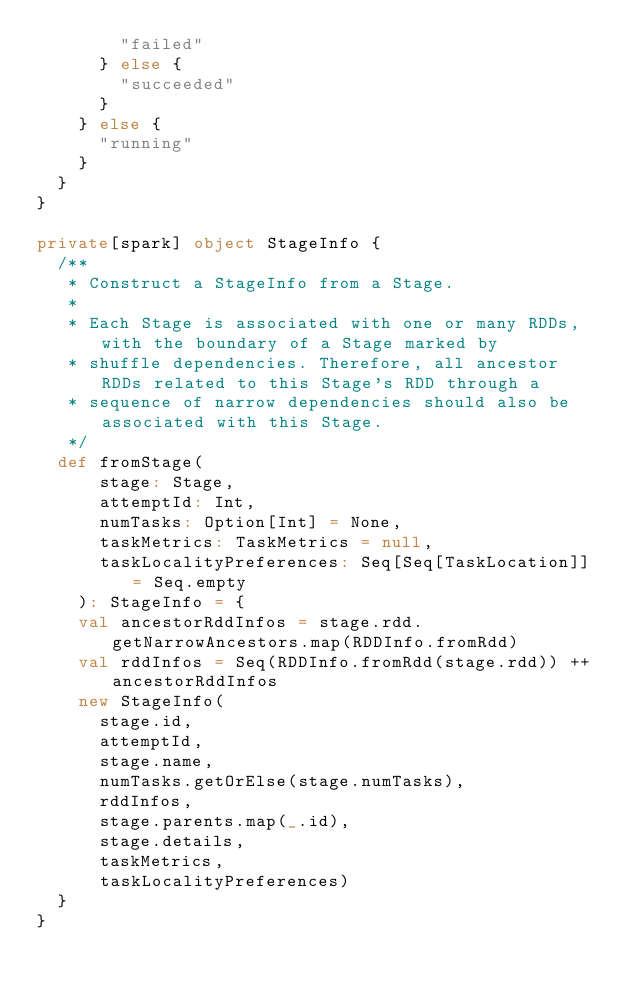Convert code to text. <code><loc_0><loc_0><loc_500><loc_500><_Scala_>        "failed"
      } else {
        "succeeded"
      }
    } else {
      "running"
    }
  }
}

private[spark] object StageInfo {
  /**
   * Construct a StageInfo from a Stage.
   *
   * Each Stage is associated with one or many RDDs, with the boundary of a Stage marked by
   * shuffle dependencies. Therefore, all ancestor RDDs related to this Stage's RDD through a
   * sequence of narrow dependencies should also be associated with this Stage.
   */
  def fromStage(
      stage: Stage,
      attemptId: Int,
      numTasks: Option[Int] = None,
      taskMetrics: TaskMetrics = null,
      taskLocalityPreferences: Seq[Seq[TaskLocation]] = Seq.empty
    ): StageInfo = {
    val ancestorRddInfos = stage.rdd.getNarrowAncestors.map(RDDInfo.fromRdd)
    val rddInfos = Seq(RDDInfo.fromRdd(stage.rdd)) ++ ancestorRddInfos
    new StageInfo(
      stage.id,
      attemptId,
      stage.name,
      numTasks.getOrElse(stage.numTasks),
      rddInfos,
      stage.parents.map(_.id),
      stage.details,
      taskMetrics,
      taskLocalityPreferences)
  }
}
</code> 